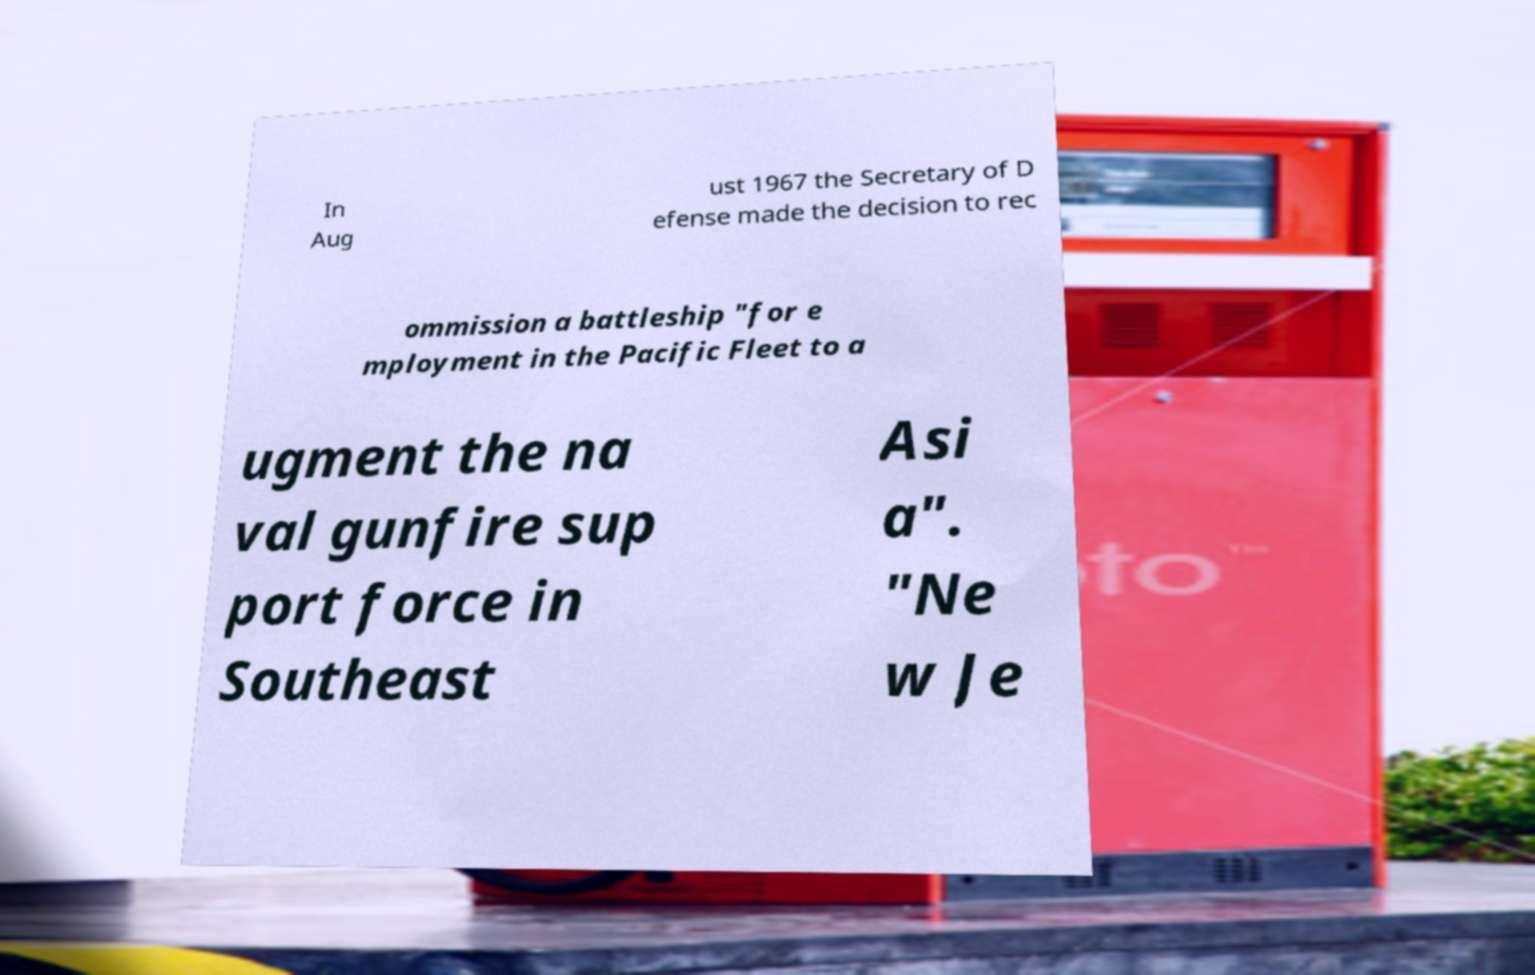Could you assist in decoding the text presented in this image and type it out clearly? In Aug ust 1967 the Secretary of D efense made the decision to rec ommission a battleship "for e mployment in the Pacific Fleet to a ugment the na val gunfire sup port force in Southeast Asi a". "Ne w Je 